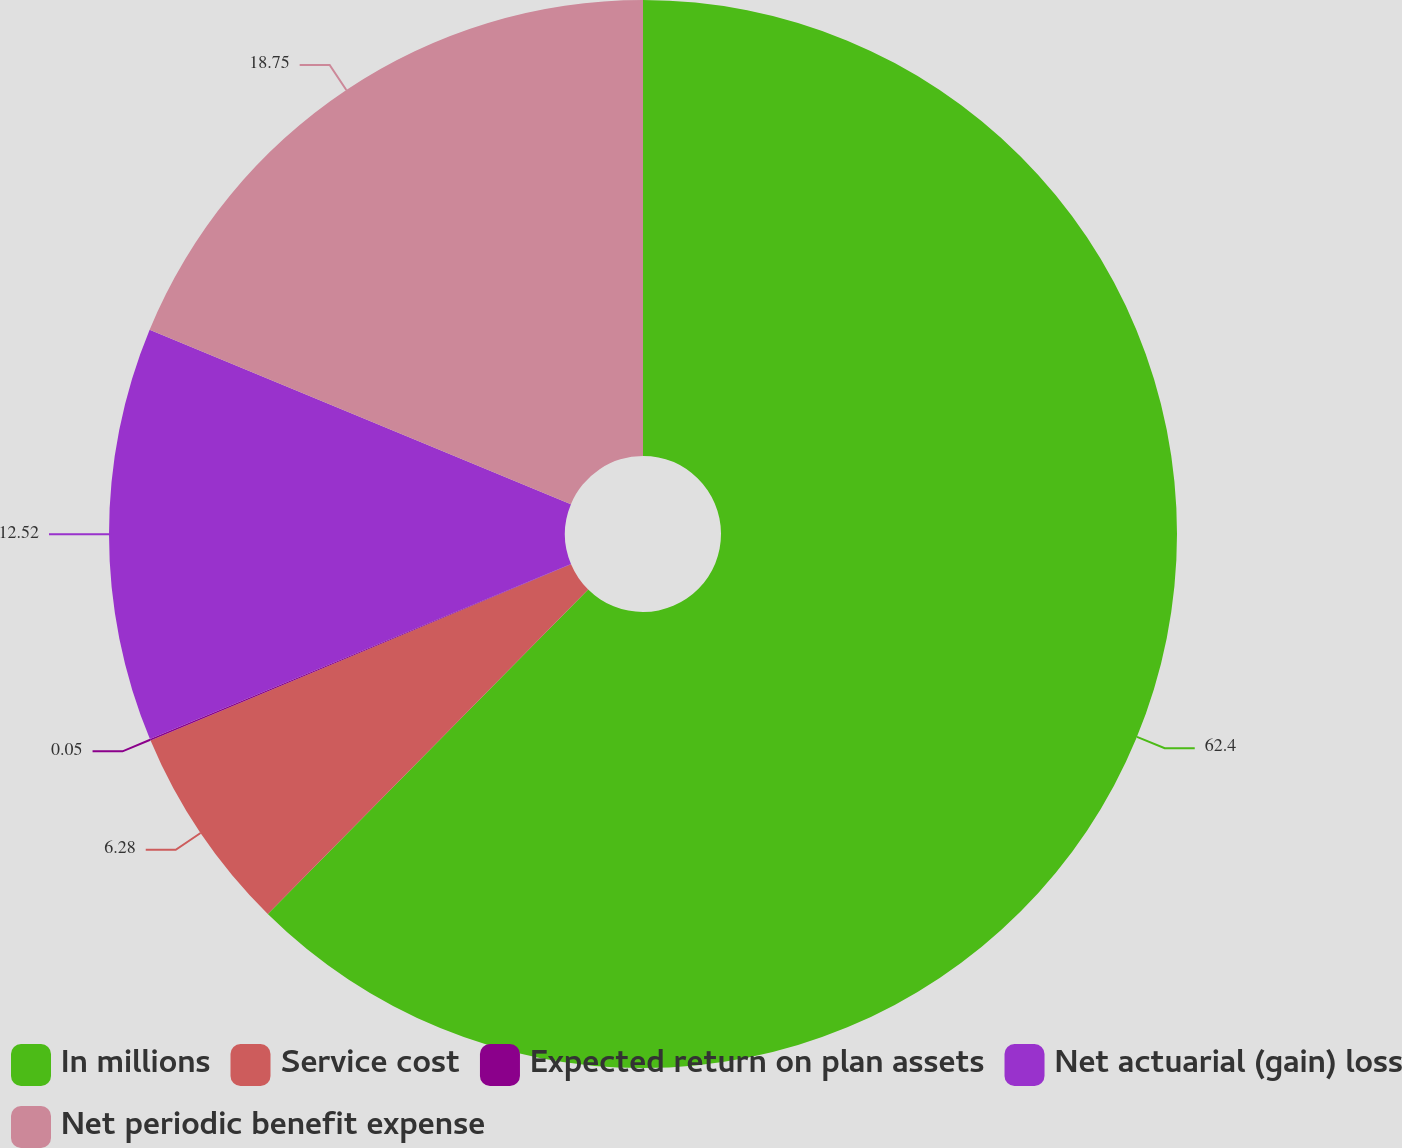Convert chart to OTSL. <chart><loc_0><loc_0><loc_500><loc_500><pie_chart><fcel>In millions<fcel>Service cost<fcel>Expected return on plan assets<fcel>Net actuarial (gain) loss<fcel>Net periodic benefit expense<nl><fcel>62.4%<fcel>6.28%<fcel>0.05%<fcel>12.52%<fcel>18.75%<nl></chart> 